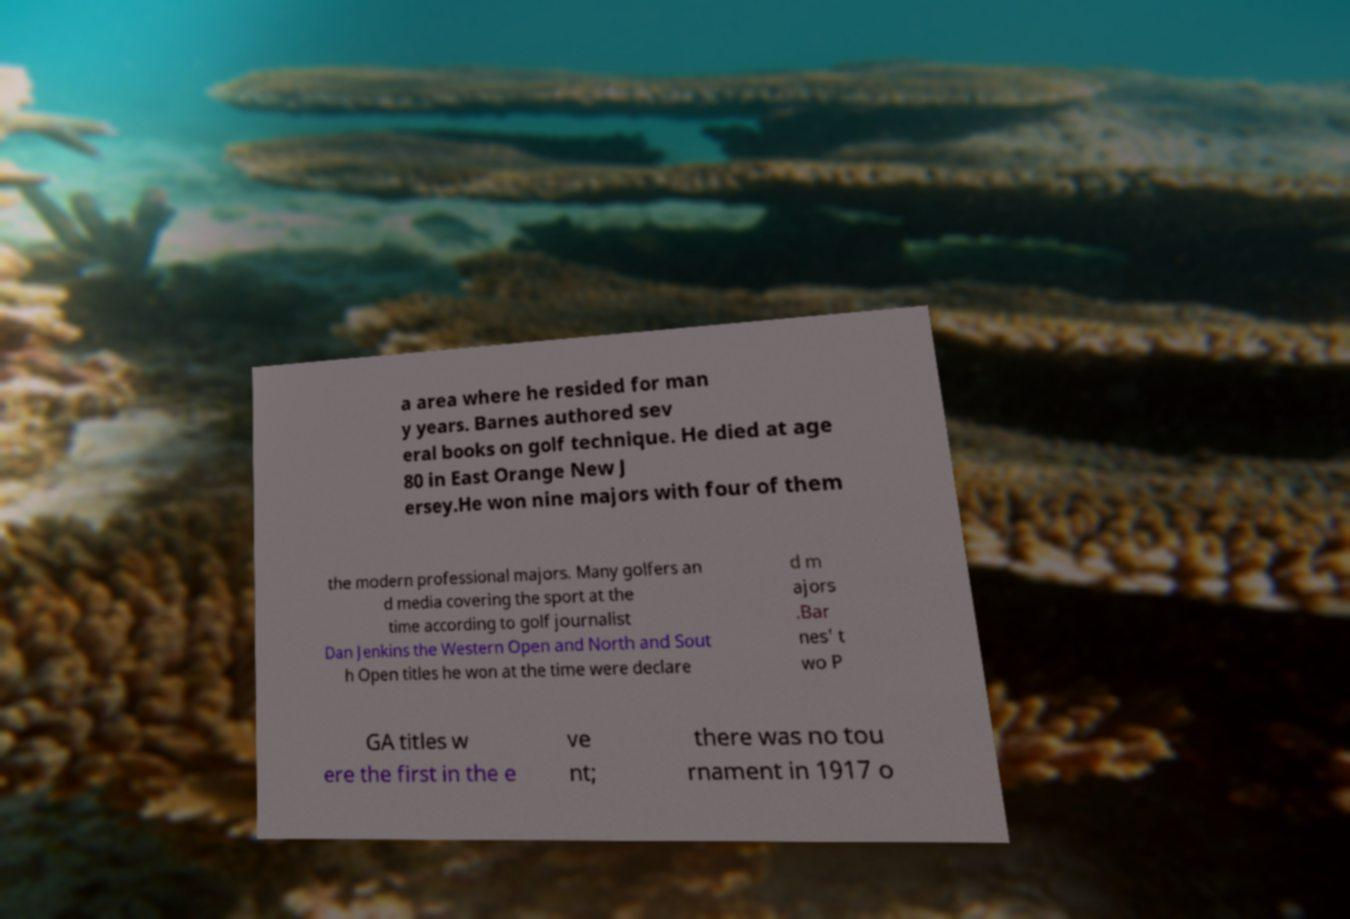Please read and relay the text visible in this image. What does it say? a area where he resided for man y years. Barnes authored sev eral books on golf technique. He died at age 80 in East Orange New J ersey.He won nine majors with four of them the modern professional majors. Many golfers an d media covering the sport at the time according to golf journalist Dan Jenkins the Western Open and North and Sout h Open titles he won at the time were declare d m ajors .Bar nes' t wo P GA titles w ere the first in the e ve nt; there was no tou rnament in 1917 o 